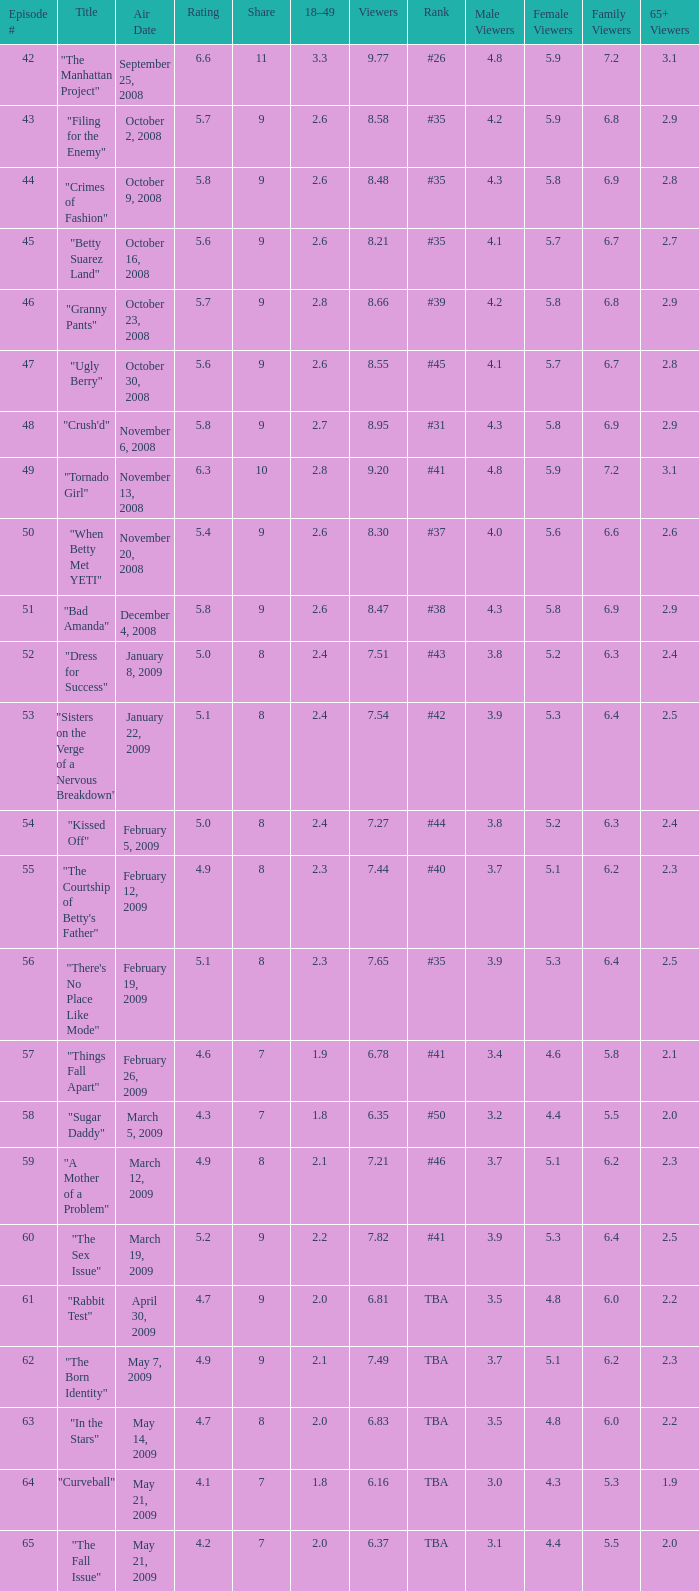What is the Air Date that has a 18–49 larger than 1.9, less than 7.54 viewers and a rating less than 4.9? April 30, 2009, May 14, 2009, May 21, 2009. 